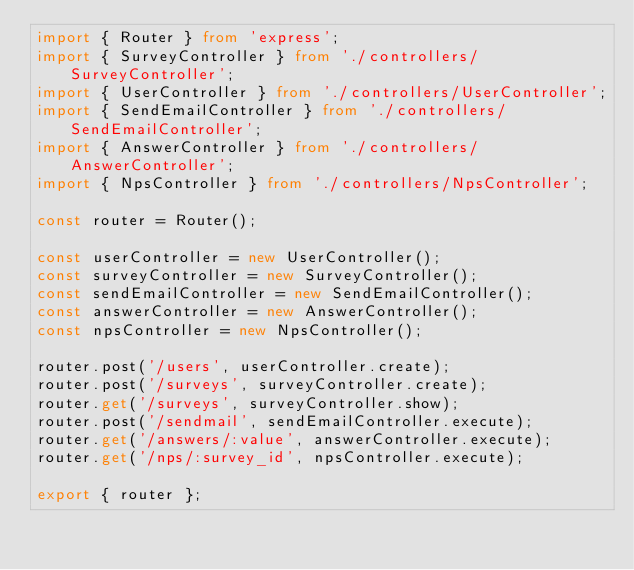Convert code to text. <code><loc_0><loc_0><loc_500><loc_500><_TypeScript_>import { Router } from 'express';
import { SurveyController } from './controllers/SurveyController';
import { UserController } from './controllers/UserController';
import { SendEmailController } from './controllers/SendEmailController';
import { AnswerController } from './controllers/AnswerController';
import { NpsController } from './controllers/NpsController';

const router = Router();

const userController = new UserController();
const surveyController = new SurveyController();
const sendEmailController = new SendEmailController();
const answerController = new AnswerController();
const npsController = new NpsController();

router.post('/users', userController.create);
router.post('/surveys', surveyController.create);
router.get('/surveys', surveyController.show);
router.post('/sendmail', sendEmailController.execute);
router.get('/answers/:value', answerController.execute);
router.get('/nps/:survey_id', npsController.execute);

export { router };
</code> 